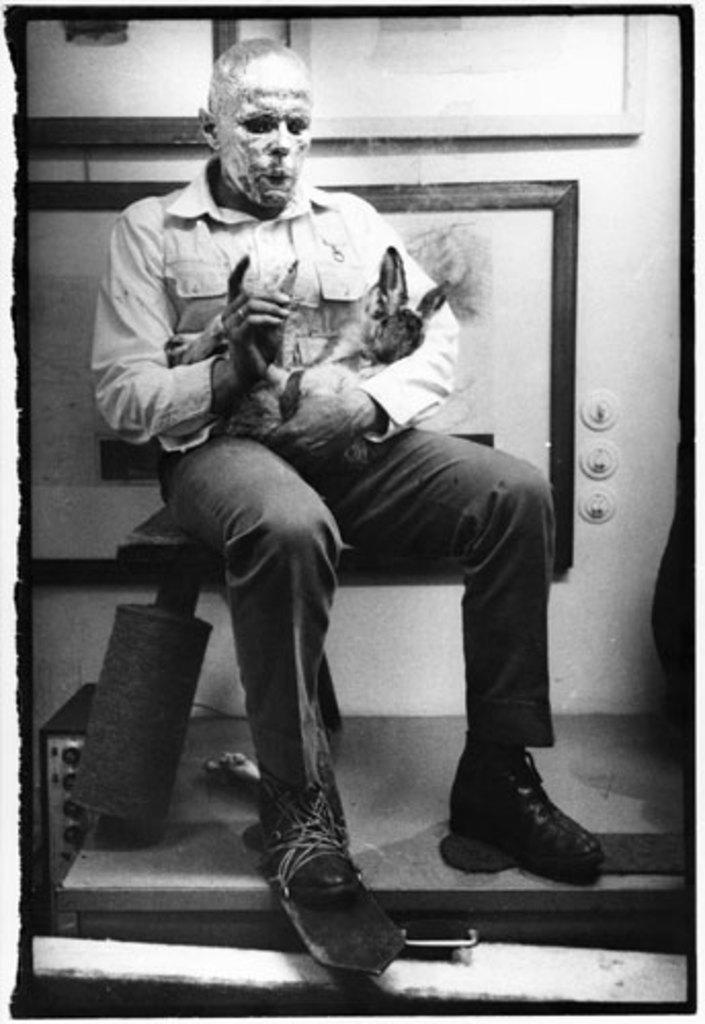Describe this image in one or two sentences. In the middle of the picture we can see a person sitting, he is holding an animal. In the background there are frames. The picture has some white border. 